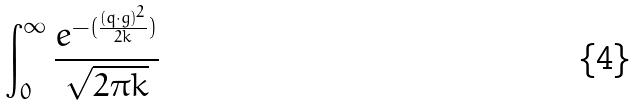<formula> <loc_0><loc_0><loc_500><loc_500>\int _ { 0 } ^ { \infty } \frac { e ^ { - ( \frac { ( q \cdot g ) ^ { 2 } } { 2 k } ) } } { \sqrt { 2 \pi k } }</formula> 